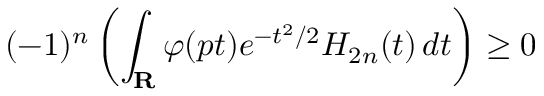<formula> <loc_0><loc_0><loc_500><loc_500>( - 1 ) ^ { n } \left ( \int _ { R } \varphi ( p t ) e ^ { - t ^ { 2 } / 2 } H _ { 2 n } ( t ) \, d t \right ) \geq 0</formula> 